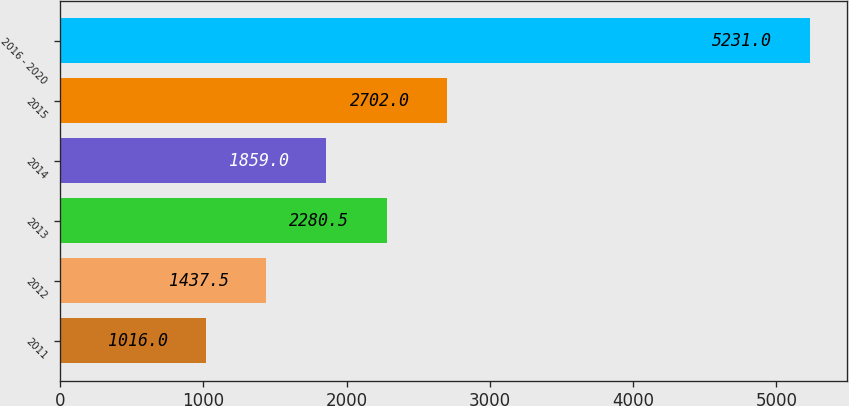Convert chart. <chart><loc_0><loc_0><loc_500><loc_500><bar_chart><fcel>2011<fcel>2012<fcel>2013<fcel>2014<fcel>2015<fcel>2016 - 2020<nl><fcel>1016<fcel>1437.5<fcel>2280.5<fcel>1859<fcel>2702<fcel>5231<nl></chart> 